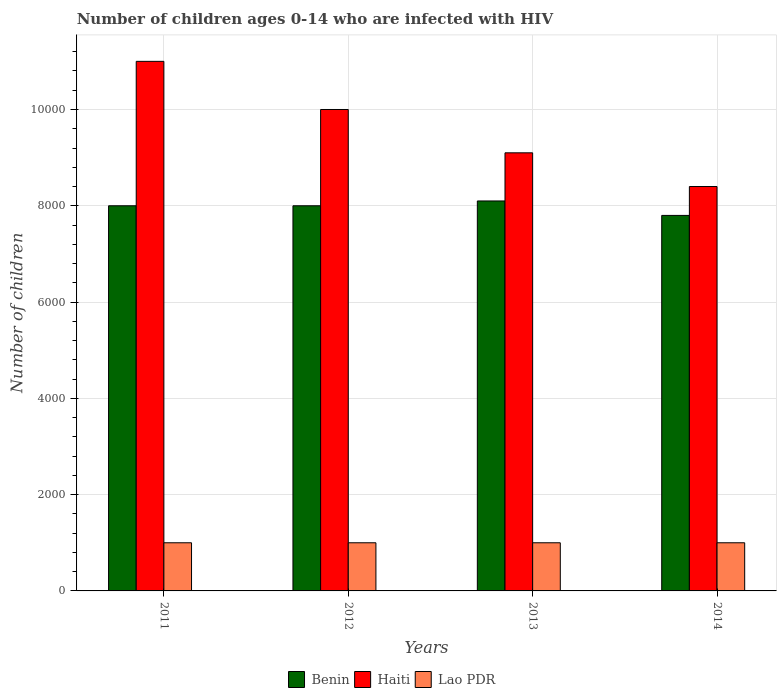How many groups of bars are there?
Keep it short and to the point. 4. Are the number of bars per tick equal to the number of legend labels?
Your answer should be very brief. Yes. Are the number of bars on each tick of the X-axis equal?
Provide a short and direct response. Yes. How many bars are there on the 2nd tick from the left?
Offer a terse response. 3. What is the label of the 3rd group of bars from the left?
Ensure brevity in your answer.  2013. What is the number of HIV infected children in Lao PDR in 2014?
Offer a terse response. 1000. Across all years, what is the maximum number of HIV infected children in Haiti?
Offer a terse response. 1.10e+04. Across all years, what is the minimum number of HIV infected children in Benin?
Provide a short and direct response. 7800. In which year was the number of HIV infected children in Haiti minimum?
Give a very brief answer. 2014. What is the total number of HIV infected children in Haiti in the graph?
Offer a very short reply. 3.85e+04. What is the difference between the number of HIV infected children in Lao PDR in 2011 and the number of HIV infected children in Benin in 2014?
Provide a succinct answer. -6800. What is the average number of HIV infected children in Benin per year?
Offer a very short reply. 7975. In the year 2011, what is the difference between the number of HIV infected children in Haiti and number of HIV infected children in Lao PDR?
Provide a succinct answer. 10000. What is the ratio of the number of HIV infected children in Benin in 2011 to that in 2013?
Offer a very short reply. 0.99. Is the difference between the number of HIV infected children in Haiti in 2011 and 2012 greater than the difference between the number of HIV infected children in Lao PDR in 2011 and 2012?
Give a very brief answer. Yes. Is the sum of the number of HIV infected children in Benin in 2013 and 2014 greater than the maximum number of HIV infected children in Haiti across all years?
Your answer should be compact. Yes. What does the 3rd bar from the left in 2012 represents?
Your answer should be compact. Lao PDR. What does the 2nd bar from the right in 2013 represents?
Keep it short and to the point. Haiti. Is it the case that in every year, the sum of the number of HIV infected children in Haiti and number of HIV infected children in Benin is greater than the number of HIV infected children in Lao PDR?
Offer a terse response. Yes. Are all the bars in the graph horizontal?
Your response must be concise. No. What is the difference between two consecutive major ticks on the Y-axis?
Provide a succinct answer. 2000. Does the graph contain grids?
Give a very brief answer. Yes. What is the title of the graph?
Your answer should be very brief. Number of children ages 0-14 who are infected with HIV. What is the label or title of the X-axis?
Provide a succinct answer. Years. What is the label or title of the Y-axis?
Ensure brevity in your answer.  Number of children. What is the Number of children in Benin in 2011?
Offer a terse response. 8000. What is the Number of children of Haiti in 2011?
Make the answer very short. 1.10e+04. What is the Number of children of Benin in 2012?
Give a very brief answer. 8000. What is the Number of children in Lao PDR in 2012?
Your answer should be compact. 1000. What is the Number of children in Benin in 2013?
Ensure brevity in your answer.  8100. What is the Number of children in Haiti in 2013?
Offer a terse response. 9100. What is the Number of children in Benin in 2014?
Offer a very short reply. 7800. What is the Number of children in Haiti in 2014?
Your answer should be very brief. 8400. What is the Number of children of Lao PDR in 2014?
Your answer should be very brief. 1000. Across all years, what is the maximum Number of children of Benin?
Your answer should be very brief. 8100. Across all years, what is the maximum Number of children in Haiti?
Your answer should be very brief. 1.10e+04. Across all years, what is the maximum Number of children in Lao PDR?
Make the answer very short. 1000. Across all years, what is the minimum Number of children in Benin?
Make the answer very short. 7800. Across all years, what is the minimum Number of children of Haiti?
Make the answer very short. 8400. Across all years, what is the minimum Number of children of Lao PDR?
Provide a succinct answer. 1000. What is the total Number of children in Benin in the graph?
Provide a short and direct response. 3.19e+04. What is the total Number of children in Haiti in the graph?
Make the answer very short. 3.85e+04. What is the total Number of children in Lao PDR in the graph?
Your answer should be very brief. 4000. What is the difference between the Number of children in Haiti in 2011 and that in 2012?
Your answer should be compact. 1000. What is the difference between the Number of children of Benin in 2011 and that in 2013?
Make the answer very short. -100. What is the difference between the Number of children in Haiti in 2011 and that in 2013?
Make the answer very short. 1900. What is the difference between the Number of children of Lao PDR in 2011 and that in 2013?
Keep it short and to the point. 0. What is the difference between the Number of children in Benin in 2011 and that in 2014?
Make the answer very short. 200. What is the difference between the Number of children of Haiti in 2011 and that in 2014?
Offer a very short reply. 2600. What is the difference between the Number of children of Benin in 2012 and that in 2013?
Make the answer very short. -100. What is the difference between the Number of children of Haiti in 2012 and that in 2013?
Provide a short and direct response. 900. What is the difference between the Number of children of Benin in 2012 and that in 2014?
Offer a terse response. 200. What is the difference between the Number of children of Haiti in 2012 and that in 2014?
Offer a very short reply. 1600. What is the difference between the Number of children in Lao PDR in 2012 and that in 2014?
Provide a short and direct response. 0. What is the difference between the Number of children in Benin in 2013 and that in 2014?
Offer a very short reply. 300. What is the difference between the Number of children in Haiti in 2013 and that in 2014?
Provide a succinct answer. 700. What is the difference between the Number of children in Benin in 2011 and the Number of children in Haiti in 2012?
Your answer should be compact. -2000. What is the difference between the Number of children in Benin in 2011 and the Number of children in Lao PDR in 2012?
Make the answer very short. 7000. What is the difference between the Number of children of Benin in 2011 and the Number of children of Haiti in 2013?
Provide a succinct answer. -1100. What is the difference between the Number of children in Benin in 2011 and the Number of children in Lao PDR in 2013?
Make the answer very short. 7000. What is the difference between the Number of children of Haiti in 2011 and the Number of children of Lao PDR in 2013?
Keep it short and to the point. 10000. What is the difference between the Number of children of Benin in 2011 and the Number of children of Haiti in 2014?
Your answer should be compact. -400. What is the difference between the Number of children of Benin in 2011 and the Number of children of Lao PDR in 2014?
Ensure brevity in your answer.  7000. What is the difference between the Number of children of Haiti in 2011 and the Number of children of Lao PDR in 2014?
Your answer should be compact. 10000. What is the difference between the Number of children in Benin in 2012 and the Number of children in Haiti in 2013?
Ensure brevity in your answer.  -1100. What is the difference between the Number of children of Benin in 2012 and the Number of children of Lao PDR in 2013?
Ensure brevity in your answer.  7000. What is the difference between the Number of children in Haiti in 2012 and the Number of children in Lao PDR in 2013?
Offer a terse response. 9000. What is the difference between the Number of children of Benin in 2012 and the Number of children of Haiti in 2014?
Ensure brevity in your answer.  -400. What is the difference between the Number of children of Benin in 2012 and the Number of children of Lao PDR in 2014?
Your answer should be compact. 7000. What is the difference between the Number of children in Haiti in 2012 and the Number of children in Lao PDR in 2014?
Your response must be concise. 9000. What is the difference between the Number of children of Benin in 2013 and the Number of children of Haiti in 2014?
Your answer should be compact. -300. What is the difference between the Number of children of Benin in 2013 and the Number of children of Lao PDR in 2014?
Ensure brevity in your answer.  7100. What is the difference between the Number of children of Haiti in 2013 and the Number of children of Lao PDR in 2014?
Ensure brevity in your answer.  8100. What is the average Number of children of Benin per year?
Offer a very short reply. 7975. What is the average Number of children of Haiti per year?
Provide a short and direct response. 9625. What is the average Number of children of Lao PDR per year?
Your answer should be compact. 1000. In the year 2011, what is the difference between the Number of children of Benin and Number of children of Haiti?
Provide a short and direct response. -3000. In the year 2011, what is the difference between the Number of children of Benin and Number of children of Lao PDR?
Offer a very short reply. 7000. In the year 2011, what is the difference between the Number of children of Haiti and Number of children of Lao PDR?
Your answer should be very brief. 10000. In the year 2012, what is the difference between the Number of children in Benin and Number of children in Haiti?
Offer a very short reply. -2000. In the year 2012, what is the difference between the Number of children in Benin and Number of children in Lao PDR?
Your answer should be compact. 7000. In the year 2012, what is the difference between the Number of children of Haiti and Number of children of Lao PDR?
Ensure brevity in your answer.  9000. In the year 2013, what is the difference between the Number of children in Benin and Number of children in Haiti?
Your response must be concise. -1000. In the year 2013, what is the difference between the Number of children in Benin and Number of children in Lao PDR?
Ensure brevity in your answer.  7100. In the year 2013, what is the difference between the Number of children in Haiti and Number of children in Lao PDR?
Give a very brief answer. 8100. In the year 2014, what is the difference between the Number of children of Benin and Number of children of Haiti?
Offer a terse response. -600. In the year 2014, what is the difference between the Number of children in Benin and Number of children in Lao PDR?
Offer a very short reply. 6800. In the year 2014, what is the difference between the Number of children in Haiti and Number of children in Lao PDR?
Make the answer very short. 7400. What is the ratio of the Number of children of Lao PDR in 2011 to that in 2012?
Offer a terse response. 1. What is the ratio of the Number of children in Haiti in 2011 to that in 2013?
Offer a very short reply. 1.21. What is the ratio of the Number of children in Benin in 2011 to that in 2014?
Your answer should be compact. 1.03. What is the ratio of the Number of children in Haiti in 2011 to that in 2014?
Keep it short and to the point. 1.31. What is the ratio of the Number of children of Haiti in 2012 to that in 2013?
Your response must be concise. 1.1. What is the ratio of the Number of children of Lao PDR in 2012 to that in 2013?
Your response must be concise. 1. What is the ratio of the Number of children in Benin in 2012 to that in 2014?
Offer a terse response. 1.03. What is the ratio of the Number of children of Haiti in 2012 to that in 2014?
Ensure brevity in your answer.  1.19. What is the ratio of the Number of children in Lao PDR in 2012 to that in 2014?
Provide a succinct answer. 1. What is the ratio of the Number of children in Haiti in 2013 to that in 2014?
Provide a short and direct response. 1.08. What is the ratio of the Number of children of Lao PDR in 2013 to that in 2014?
Your answer should be compact. 1. What is the difference between the highest and the second highest Number of children in Lao PDR?
Your response must be concise. 0. What is the difference between the highest and the lowest Number of children in Benin?
Provide a short and direct response. 300. What is the difference between the highest and the lowest Number of children of Haiti?
Provide a succinct answer. 2600. What is the difference between the highest and the lowest Number of children in Lao PDR?
Provide a succinct answer. 0. 